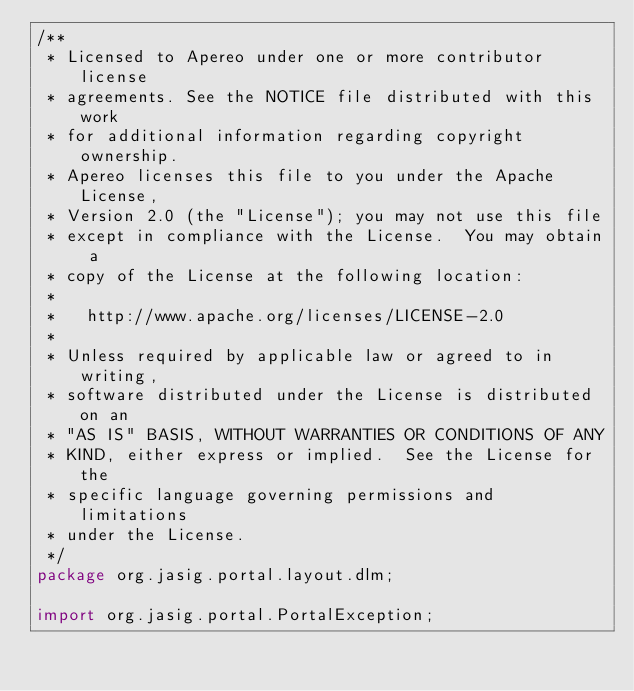<code> <loc_0><loc_0><loc_500><loc_500><_Java_>/**
 * Licensed to Apereo under one or more contributor license
 * agreements. See the NOTICE file distributed with this work
 * for additional information regarding copyright ownership.
 * Apereo licenses this file to you under the Apache License,
 * Version 2.0 (the "License"); you may not use this file
 * except in compliance with the License.  You may obtain a
 * copy of the License at the following location:
 *
 *   http://www.apache.org/licenses/LICENSE-2.0
 *
 * Unless required by applicable law or agreed to in writing,
 * software distributed under the License is distributed on an
 * "AS IS" BASIS, WITHOUT WARRANTIES OR CONDITIONS OF ANY
 * KIND, either express or implied.  See the License for the
 * specific language governing permissions and limitations
 * under the License.
 */
package org.jasig.portal.layout.dlm;

import org.jasig.portal.PortalException;</code> 